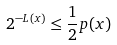Convert formula to latex. <formula><loc_0><loc_0><loc_500><loc_500>2 ^ { - L ( x ) } \leq \frac { 1 } { 2 } p ( x )</formula> 